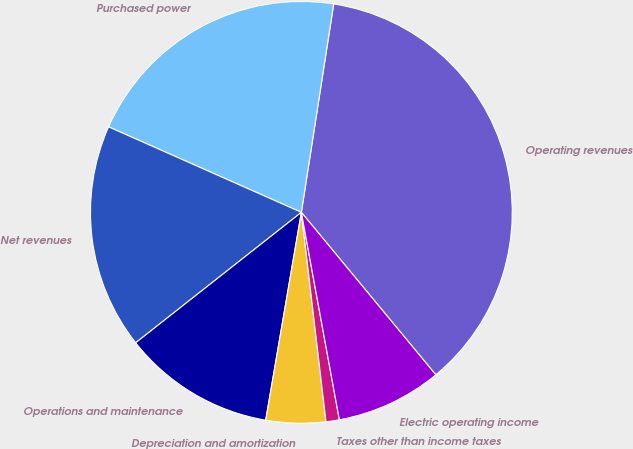<chart> <loc_0><loc_0><loc_500><loc_500><pie_chart><fcel>Operating revenues<fcel>Purchased power<fcel>Net revenues<fcel>Operations and maintenance<fcel>Depreciation and amortization<fcel>Taxes other than income taxes<fcel>Electric operating income<nl><fcel>36.55%<fcel>20.81%<fcel>17.26%<fcel>11.68%<fcel>4.57%<fcel>1.02%<fcel>8.12%<nl></chart> 